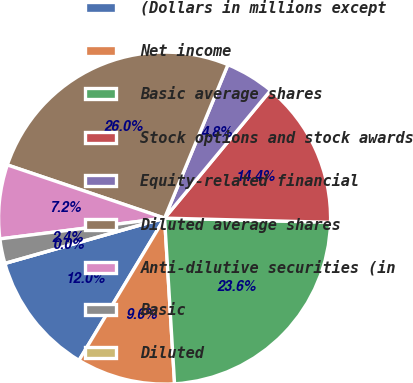Convert chart to OTSL. <chart><loc_0><loc_0><loc_500><loc_500><pie_chart><fcel>(Dollars in millions except<fcel>Net income<fcel>Basic average shares<fcel>Stock options and stock awards<fcel>Equity-related financial<fcel>Diluted average shares<fcel>Anti-dilutive securities (in<fcel>Basic<fcel>Diluted<nl><fcel>11.98%<fcel>9.58%<fcel>23.64%<fcel>14.38%<fcel>4.79%<fcel>26.04%<fcel>7.19%<fcel>2.4%<fcel>0.0%<nl></chart> 